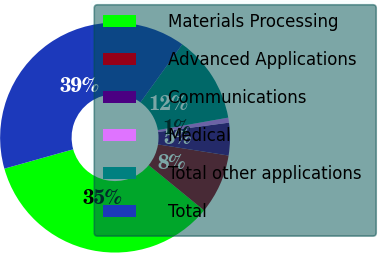Convert chart to OTSL. <chart><loc_0><loc_0><loc_500><loc_500><pie_chart><fcel>Materials Processing<fcel>Advanced Applications<fcel>Communications<fcel>Medical<fcel>Total other applications<fcel>Total<nl><fcel>34.73%<fcel>8.42%<fcel>4.57%<fcel>0.71%<fcel>12.28%<fcel>39.29%<nl></chart> 